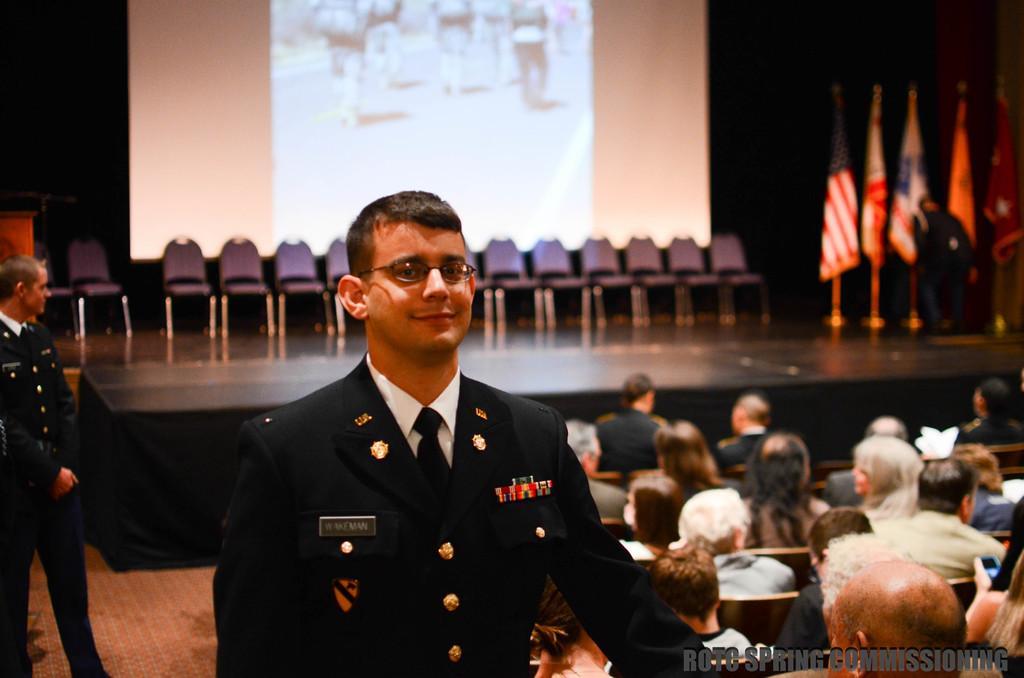How would you summarize this image in a sentence or two? In this image there is an officer standing with a smile on his face, behind him there are a few people seated on chairs, in front of them there are a few chairs and flags on the stage, behind the chairs there is a screen. 